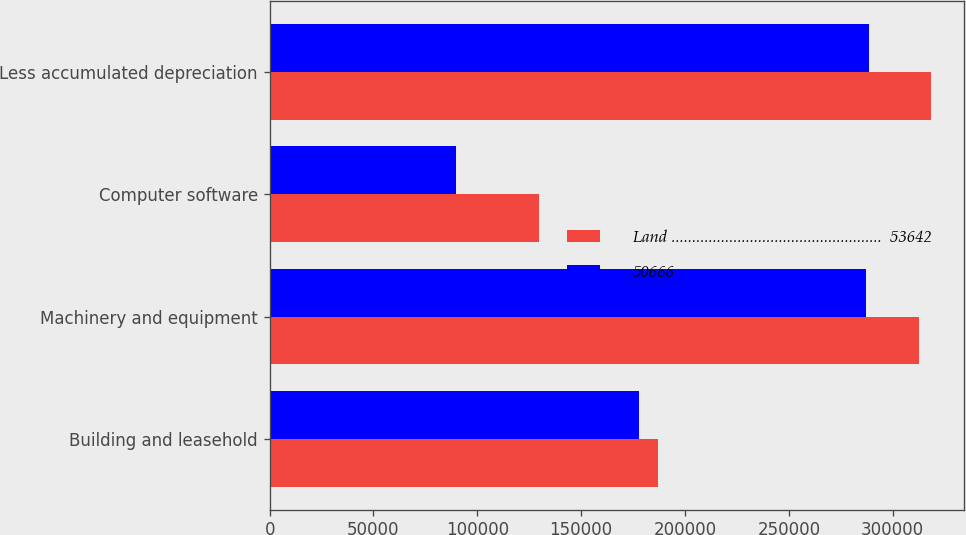<chart> <loc_0><loc_0><loc_500><loc_500><stacked_bar_chart><ecel><fcel>Building and leasehold<fcel>Machinery and equipment<fcel>Computer software<fcel>Less accumulated depreciation<nl><fcel>Land ...................................................  53642<fcel>186974<fcel>312501<fcel>129697<fcel>318342<nl><fcel>50666<fcel>177615<fcel>287247<fcel>89523<fcel>288717<nl></chart> 